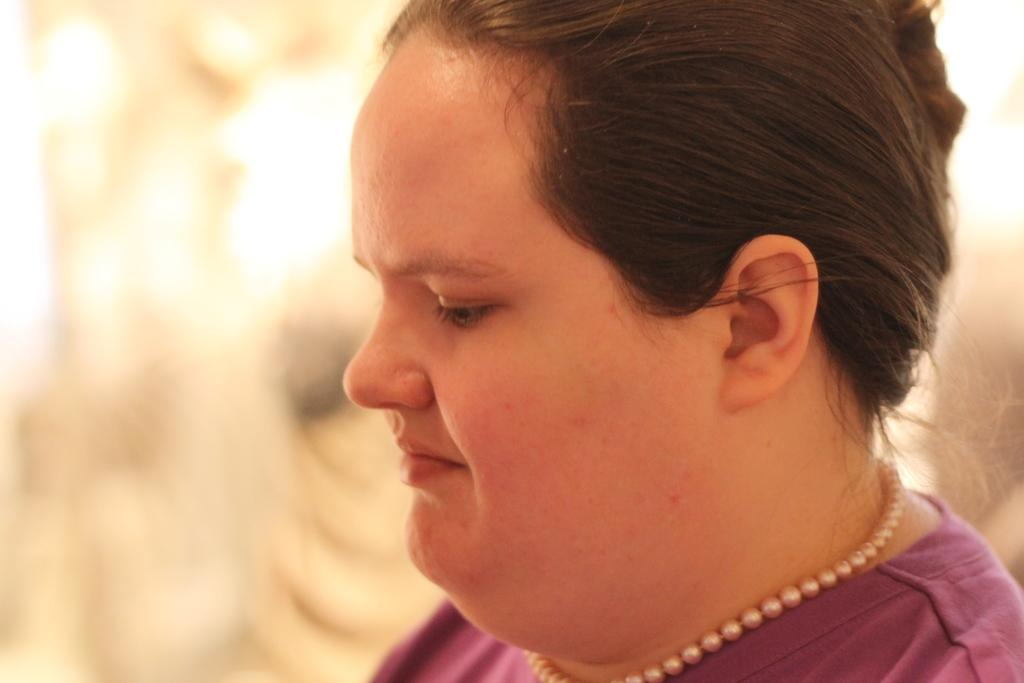Who or what is the main subject in the image? There is a person in the image. What is the person wearing around their neck? The person is wearing a pearl chain. What color is the person's t-shirt? The person is wearing a purple t-shirt. Can you describe the background of the image? The background of the image is blurred. How many trees can be seen in the image? There are no trees visible in the image; it features a person wearing a pearl chain and a purple t-shirt against a blurred background. 